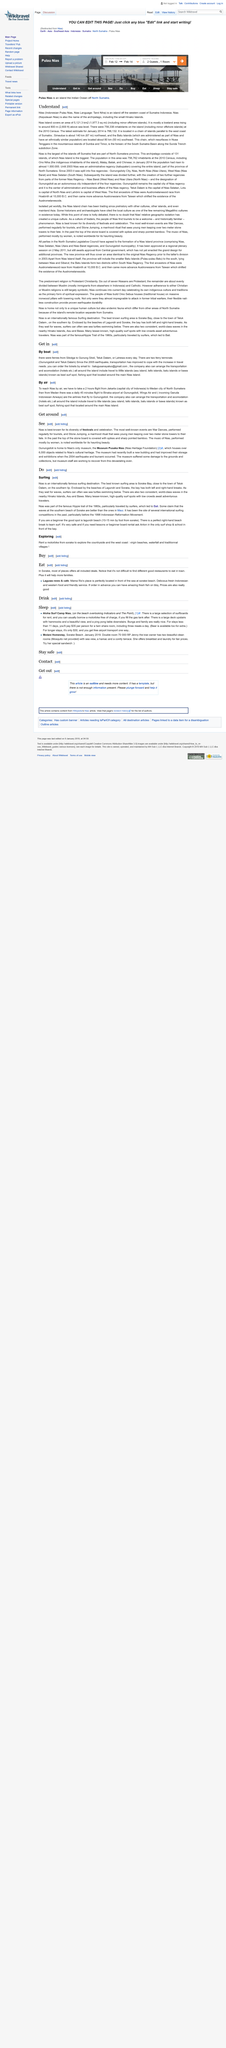Outline some significant characteristics in this image. Nias Island covers an area of approximately 5,121.3 km² including minor offshore islands, making it a relatively large island. Nias is an island located off the western coast of Sumatra, Indonesia. It is located in the Indian Ocean. Based on the 2010 census, there were 756,338 people living on the island. 